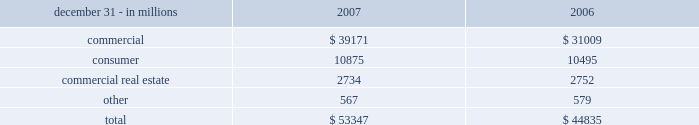Net unfunded credit commitments .
Commitments to extend credit represent arrangements to lend funds subject to specified contractual conditions .
At december 31 , 2007 , commercial commitments are reported net of $ 8.9 billion of participations , assignments and syndications , primarily to financial services companies .
The comparable amount at december 31 , 2006 was $ 8.3 billion .
Commitments generally have fixed expiration dates , may require payment of a fee , and contain termination clauses in the event the customer 2019s credit quality deteriorates .
Based on our historical experience , most commitments expire unfunded , and therefore cash requirements are substantially less than the total commitment .
Consumer home equity lines of credit accounted for 80% ( 80 % ) of consumer unfunded credit commitments .
Unfunded credit commitments related to market street totaled $ 8.8 billion at december 31 , 2007 and $ 5.6 billion at december 31 , 2006 and are included in the preceding table primarily within the 201ccommercial 201d and 201cconsumer 201d categories .
Note 24 commitments and guarantees includes information regarding standby letters of credit and bankers 2019 acceptances .
At december 31 , 2007 , the largest industry concentration was for general medical and surgical hospitals , which accounted for approximately 5% ( 5 % ) of the total letters of credit and bankers 2019 acceptances .
At december 31 , 2007 , we pledged $ 1.6 billion of loans to the federal reserve bank ( 201cfrb 201d ) and $ 33.5 billion of loans to the federal home loan bank ( 201cfhlb 201d ) as collateral for the contingent ability to borrow , if necessary .
Certain directors and executive officers of pnc and its subsidiaries , as well as certain affiliated companies of these directors and officers , were customers of and had loans with subsidiary banks in the ordinary course of business .
All such loans were on substantially the same terms , including interest rates and collateral , as those prevailing at the time for comparable transactions with other customers and did not involve more than a normal risk of collectibility or present other unfavorable features .
The aggregate principal amounts of these loans were $ 13 million at december 31 , 2007 and $ 18 million at december 31 , 2006 .
During 2007 , new loans of $ 48 million were funded and repayments totaled $ 53 million. .
What was the change in commercial commitments net of participations , assignments and syndications , primarily to financial services companies in 2007 compared to 2006 in billions? 
Computations: (8.9 - 8.3)
Answer: 0.6. 